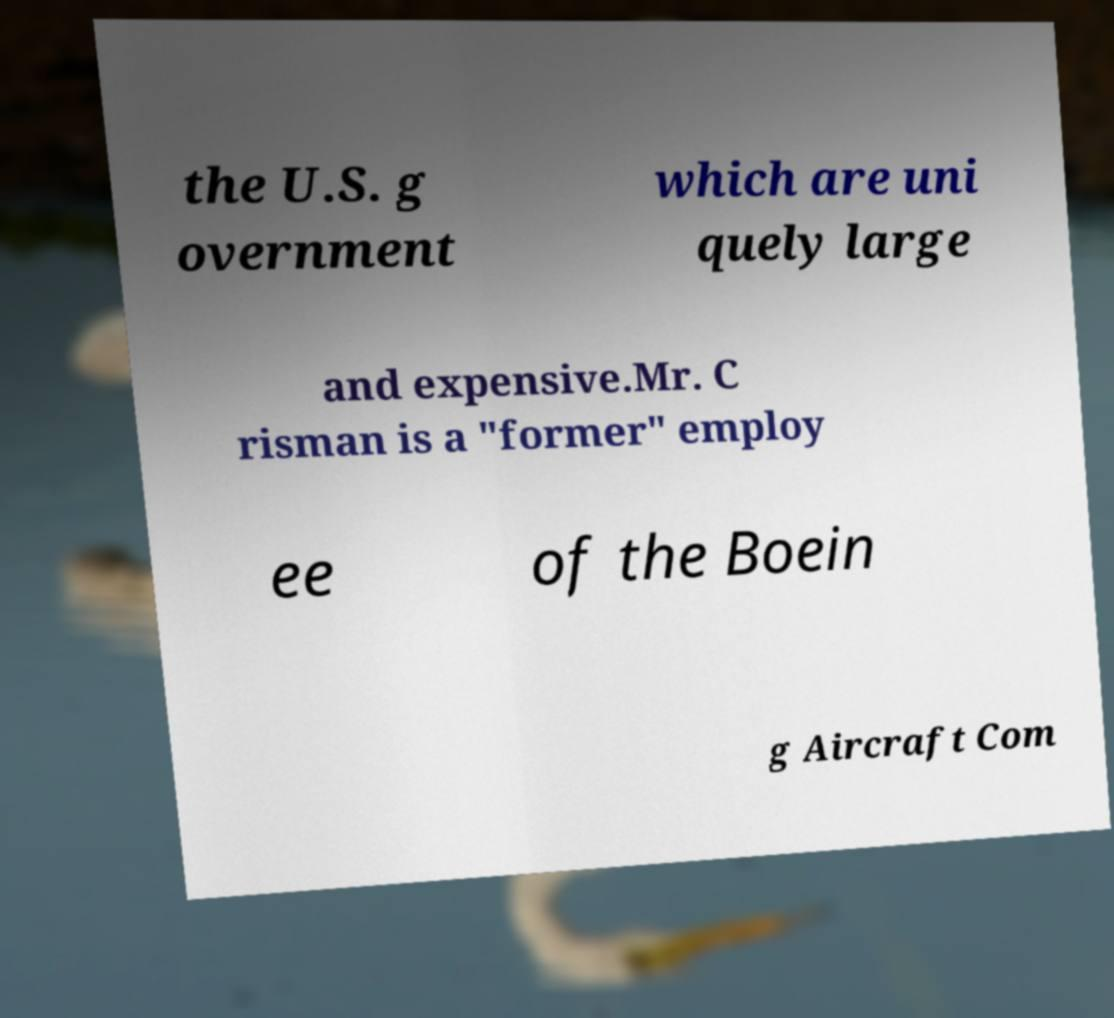For documentation purposes, I need the text within this image transcribed. Could you provide that? the U.S. g overnment which are uni quely large and expensive.Mr. C risman is a "former" employ ee of the Boein g Aircraft Com 